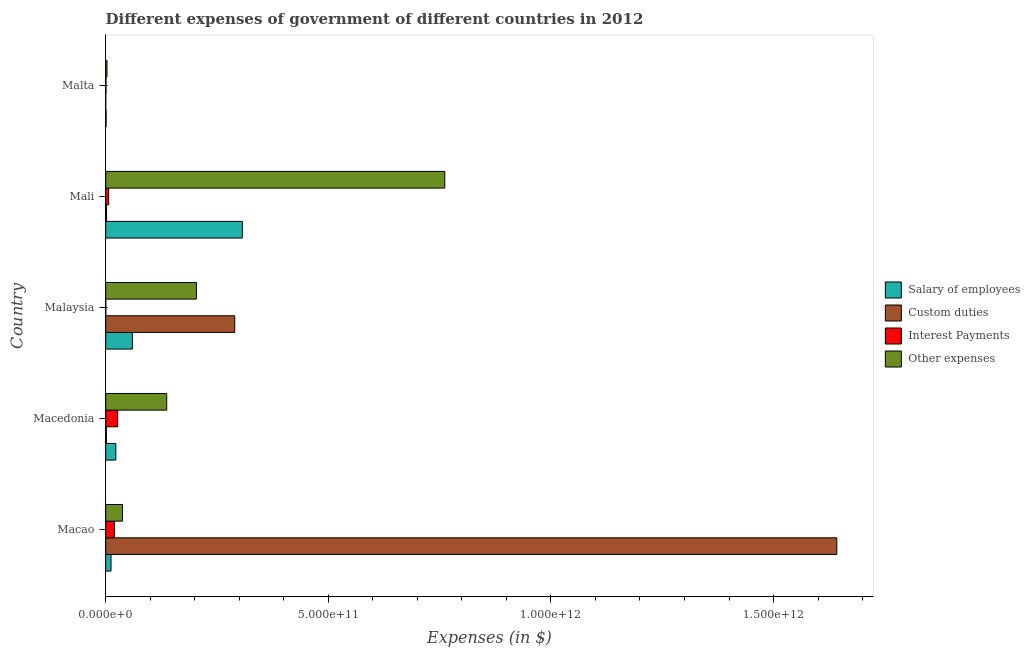How many different coloured bars are there?
Your answer should be very brief. 4. How many groups of bars are there?
Ensure brevity in your answer.  5. How many bars are there on the 2nd tick from the bottom?
Your answer should be compact. 4. What is the label of the 4th group of bars from the top?
Offer a terse response. Macedonia. What is the amount spent on other expenses in Malaysia?
Give a very brief answer. 2.04e+11. Across all countries, what is the maximum amount spent on interest payments?
Provide a succinct answer. 2.69e+1. In which country was the amount spent on interest payments maximum?
Your answer should be very brief. Macedonia. In which country was the amount spent on salary of employees minimum?
Your response must be concise. Malta. What is the total amount spent on custom duties in the graph?
Provide a succinct answer. 1.94e+12. What is the difference between the amount spent on other expenses in Macao and that in Malaysia?
Your response must be concise. -1.66e+11. What is the difference between the amount spent on other expenses in Mali and the amount spent on custom duties in Macedonia?
Offer a very short reply. 7.60e+11. What is the average amount spent on custom duties per country?
Your response must be concise. 3.87e+11. What is the difference between the amount spent on other expenses and amount spent on custom duties in Malta?
Provide a succinct answer. 2.90e+09. What is the ratio of the amount spent on interest payments in Mali to that in Malta?
Give a very brief answer. 9.92. What is the difference between the highest and the second highest amount spent on custom duties?
Your answer should be compact. 1.35e+12. What is the difference between the highest and the lowest amount spent on salary of employees?
Make the answer very short. 3.06e+11. In how many countries, is the amount spent on other expenses greater than the average amount spent on other expenses taken over all countries?
Your answer should be compact. 1. Is the sum of the amount spent on custom duties in Macedonia and Malaysia greater than the maximum amount spent on other expenses across all countries?
Offer a terse response. No. What does the 4th bar from the top in Mali represents?
Provide a succinct answer. Salary of employees. What does the 4th bar from the bottom in Malaysia represents?
Your answer should be very brief. Other expenses. How many bars are there?
Keep it short and to the point. 20. How many countries are there in the graph?
Your answer should be compact. 5. What is the difference between two consecutive major ticks on the X-axis?
Your response must be concise. 5.00e+11. Are the values on the major ticks of X-axis written in scientific E-notation?
Keep it short and to the point. Yes. Where does the legend appear in the graph?
Your response must be concise. Center right. What is the title of the graph?
Offer a very short reply. Different expenses of government of different countries in 2012. What is the label or title of the X-axis?
Make the answer very short. Expenses (in $). What is the Expenses (in $) in Salary of employees in Macao?
Offer a very short reply. 1.19e+1. What is the Expenses (in $) of Custom duties in Macao?
Your answer should be very brief. 1.64e+12. What is the Expenses (in $) in Interest Payments in Macao?
Keep it short and to the point. 1.95e+1. What is the Expenses (in $) of Other expenses in Macao?
Give a very brief answer. 3.76e+1. What is the Expenses (in $) in Salary of employees in Macedonia?
Offer a terse response. 2.27e+1. What is the Expenses (in $) in Custom duties in Macedonia?
Your answer should be very brief. 1.53e+09. What is the Expenses (in $) in Interest Payments in Macedonia?
Make the answer very short. 2.69e+1. What is the Expenses (in $) of Other expenses in Macedonia?
Offer a very short reply. 1.37e+11. What is the Expenses (in $) in Salary of employees in Malaysia?
Offer a terse response. 6.00e+1. What is the Expenses (in $) of Custom duties in Malaysia?
Make the answer very short. 2.90e+11. What is the Expenses (in $) in Interest Payments in Malaysia?
Provide a succinct answer. 2.13e+08. What is the Expenses (in $) of Other expenses in Malaysia?
Offer a terse response. 2.04e+11. What is the Expenses (in $) in Salary of employees in Mali?
Ensure brevity in your answer.  3.07e+11. What is the Expenses (in $) of Custom duties in Mali?
Provide a short and direct response. 1.95e+09. What is the Expenses (in $) of Interest Payments in Mali?
Provide a short and direct response. 6.61e+09. What is the Expenses (in $) of Other expenses in Mali?
Offer a terse response. 7.62e+11. What is the Expenses (in $) of Salary of employees in Malta?
Provide a succinct answer. 9.07e+08. What is the Expenses (in $) of Custom duties in Malta?
Make the answer very short. 1.00e+06. What is the Expenses (in $) in Interest Payments in Malta?
Your answer should be very brief. 6.66e+08. What is the Expenses (in $) in Other expenses in Malta?
Offer a very short reply. 2.90e+09. Across all countries, what is the maximum Expenses (in $) in Salary of employees?
Your response must be concise. 3.07e+11. Across all countries, what is the maximum Expenses (in $) of Custom duties?
Offer a terse response. 1.64e+12. Across all countries, what is the maximum Expenses (in $) of Interest Payments?
Make the answer very short. 2.69e+1. Across all countries, what is the maximum Expenses (in $) in Other expenses?
Ensure brevity in your answer.  7.62e+11. Across all countries, what is the minimum Expenses (in $) of Salary of employees?
Your response must be concise. 9.07e+08. Across all countries, what is the minimum Expenses (in $) in Interest Payments?
Ensure brevity in your answer.  2.13e+08. Across all countries, what is the minimum Expenses (in $) of Other expenses?
Offer a terse response. 2.90e+09. What is the total Expenses (in $) in Salary of employees in the graph?
Give a very brief answer. 4.02e+11. What is the total Expenses (in $) in Custom duties in the graph?
Ensure brevity in your answer.  1.94e+12. What is the total Expenses (in $) of Interest Payments in the graph?
Provide a succinct answer. 5.39e+1. What is the total Expenses (in $) of Other expenses in the graph?
Provide a succinct answer. 1.14e+12. What is the difference between the Expenses (in $) of Salary of employees in Macao and that in Macedonia?
Keep it short and to the point. -1.08e+1. What is the difference between the Expenses (in $) in Custom duties in Macao and that in Macedonia?
Give a very brief answer. 1.64e+12. What is the difference between the Expenses (in $) in Interest Payments in Macao and that in Macedonia?
Your response must be concise. -7.35e+09. What is the difference between the Expenses (in $) in Other expenses in Macao and that in Macedonia?
Your answer should be very brief. -9.95e+1. What is the difference between the Expenses (in $) of Salary of employees in Macao and that in Malaysia?
Provide a succinct answer. -4.81e+1. What is the difference between the Expenses (in $) in Custom duties in Macao and that in Malaysia?
Make the answer very short. 1.35e+12. What is the difference between the Expenses (in $) in Interest Payments in Macao and that in Malaysia?
Ensure brevity in your answer.  1.93e+1. What is the difference between the Expenses (in $) of Other expenses in Macao and that in Malaysia?
Give a very brief answer. -1.66e+11. What is the difference between the Expenses (in $) of Salary of employees in Macao and that in Mali?
Offer a terse response. -2.95e+11. What is the difference between the Expenses (in $) in Custom duties in Macao and that in Mali?
Make the answer very short. 1.64e+12. What is the difference between the Expenses (in $) in Interest Payments in Macao and that in Mali?
Provide a succinct answer. 1.29e+1. What is the difference between the Expenses (in $) of Other expenses in Macao and that in Mali?
Your answer should be very brief. -7.24e+11. What is the difference between the Expenses (in $) of Salary of employees in Macao and that in Malta?
Offer a terse response. 1.10e+1. What is the difference between the Expenses (in $) in Custom duties in Macao and that in Malta?
Provide a short and direct response. 1.64e+12. What is the difference between the Expenses (in $) in Interest Payments in Macao and that in Malta?
Your response must be concise. 1.89e+1. What is the difference between the Expenses (in $) of Other expenses in Macao and that in Malta?
Make the answer very short. 3.47e+1. What is the difference between the Expenses (in $) of Salary of employees in Macedonia and that in Malaysia?
Offer a terse response. -3.73e+1. What is the difference between the Expenses (in $) of Custom duties in Macedonia and that in Malaysia?
Make the answer very short. -2.88e+11. What is the difference between the Expenses (in $) of Interest Payments in Macedonia and that in Malaysia?
Provide a short and direct response. 2.67e+1. What is the difference between the Expenses (in $) in Other expenses in Macedonia and that in Malaysia?
Your answer should be very brief. -6.67e+1. What is the difference between the Expenses (in $) of Salary of employees in Macedonia and that in Mali?
Give a very brief answer. -2.84e+11. What is the difference between the Expenses (in $) in Custom duties in Macedonia and that in Mali?
Offer a very short reply. -4.24e+08. What is the difference between the Expenses (in $) of Interest Payments in Macedonia and that in Mali?
Your response must be concise. 2.03e+1. What is the difference between the Expenses (in $) of Other expenses in Macedonia and that in Mali?
Your response must be concise. -6.25e+11. What is the difference between the Expenses (in $) in Salary of employees in Macedonia and that in Malta?
Your response must be concise. 2.18e+1. What is the difference between the Expenses (in $) in Custom duties in Macedonia and that in Malta?
Offer a terse response. 1.53e+09. What is the difference between the Expenses (in $) in Interest Payments in Macedonia and that in Malta?
Your response must be concise. 2.62e+1. What is the difference between the Expenses (in $) of Other expenses in Macedonia and that in Malta?
Provide a short and direct response. 1.34e+11. What is the difference between the Expenses (in $) in Salary of employees in Malaysia and that in Mali?
Your response must be concise. -2.47e+11. What is the difference between the Expenses (in $) in Custom duties in Malaysia and that in Mali?
Offer a very short reply. 2.88e+11. What is the difference between the Expenses (in $) of Interest Payments in Malaysia and that in Mali?
Provide a short and direct response. -6.40e+09. What is the difference between the Expenses (in $) in Other expenses in Malaysia and that in Mali?
Offer a very short reply. -5.58e+11. What is the difference between the Expenses (in $) in Salary of employees in Malaysia and that in Malta?
Your response must be concise. 5.91e+1. What is the difference between the Expenses (in $) in Custom duties in Malaysia and that in Malta?
Offer a terse response. 2.90e+11. What is the difference between the Expenses (in $) of Interest Payments in Malaysia and that in Malta?
Make the answer very short. -4.54e+08. What is the difference between the Expenses (in $) of Other expenses in Malaysia and that in Malta?
Provide a succinct answer. 2.01e+11. What is the difference between the Expenses (in $) in Salary of employees in Mali and that in Malta?
Offer a very short reply. 3.06e+11. What is the difference between the Expenses (in $) in Custom duties in Mali and that in Malta?
Make the answer very short. 1.95e+09. What is the difference between the Expenses (in $) in Interest Payments in Mali and that in Malta?
Your answer should be very brief. 5.94e+09. What is the difference between the Expenses (in $) of Other expenses in Mali and that in Malta?
Make the answer very short. 7.59e+11. What is the difference between the Expenses (in $) of Salary of employees in Macao and the Expenses (in $) of Custom duties in Macedonia?
Ensure brevity in your answer.  1.04e+1. What is the difference between the Expenses (in $) of Salary of employees in Macao and the Expenses (in $) of Interest Payments in Macedonia?
Your answer should be very brief. -1.49e+1. What is the difference between the Expenses (in $) of Salary of employees in Macao and the Expenses (in $) of Other expenses in Macedonia?
Provide a short and direct response. -1.25e+11. What is the difference between the Expenses (in $) of Custom duties in Macao and the Expenses (in $) of Interest Payments in Macedonia?
Give a very brief answer. 1.62e+12. What is the difference between the Expenses (in $) of Custom duties in Macao and the Expenses (in $) of Other expenses in Macedonia?
Ensure brevity in your answer.  1.50e+12. What is the difference between the Expenses (in $) of Interest Payments in Macao and the Expenses (in $) of Other expenses in Macedonia?
Ensure brevity in your answer.  -1.18e+11. What is the difference between the Expenses (in $) of Salary of employees in Macao and the Expenses (in $) of Custom duties in Malaysia?
Provide a succinct answer. -2.78e+11. What is the difference between the Expenses (in $) of Salary of employees in Macao and the Expenses (in $) of Interest Payments in Malaysia?
Ensure brevity in your answer.  1.17e+1. What is the difference between the Expenses (in $) in Salary of employees in Macao and the Expenses (in $) in Other expenses in Malaysia?
Make the answer very short. -1.92e+11. What is the difference between the Expenses (in $) in Custom duties in Macao and the Expenses (in $) in Interest Payments in Malaysia?
Provide a succinct answer. 1.64e+12. What is the difference between the Expenses (in $) of Custom duties in Macao and the Expenses (in $) of Other expenses in Malaysia?
Ensure brevity in your answer.  1.44e+12. What is the difference between the Expenses (in $) in Interest Payments in Macao and the Expenses (in $) in Other expenses in Malaysia?
Your answer should be very brief. -1.84e+11. What is the difference between the Expenses (in $) of Salary of employees in Macao and the Expenses (in $) of Custom duties in Mali?
Your response must be concise. 9.99e+09. What is the difference between the Expenses (in $) in Salary of employees in Macao and the Expenses (in $) in Interest Payments in Mali?
Give a very brief answer. 5.33e+09. What is the difference between the Expenses (in $) in Salary of employees in Macao and the Expenses (in $) in Other expenses in Mali?
Keep it short and to the point. -7.50e+11. What is the difference between the Expenses (in $) of Custom duties in Macao and the Expenses (in $) of Interest Payments in Mali?
Keep it short and to the point. 1.64e+12. What is the difference between the Expenses (in $) of Custom duties in Macao and the Expenses (in $) of Other expenses in Mali?
Ensure brevity in your answer.  8.80e+11. What is the difference between the Expenses (in $) of Interest Payments in Macao and the Expenses (in $) of Other expenses in Mali?
Make the answer very short. -7.42e+11. What is the difference between the Expenses (in $) in Salary of employees in Macao and the Expenses (in $) in Custom duties in Malta?
Keep it short and to the point. 1.19e+1. What is the difference between the Expenses (in $) in Salary of employees in Macao and the Expenses (in $) in Interest Payments in Malta?
Keep it short and to the point. 1.13e+1. What is the difference between the Expenses (in $) in Salary of employees in Macao and the Expenses (in $) in Other expenses in Malta?
Give a very brief answer. 9.04e+09. What is the difference between the Expenses (in $) of Custom duties in Macao and the Expenses (in $) of Interest Payments in Malta?
Give a very brief answer. 1.64e+12. What is the difference between the Expenses (in $) in Custom duties in Macao and the Expenses (in $) in Other expenses in Malta?
Offer a very short reply. 1.64e+12. What is the difference between the Expenses (in $) in Interest Payments in Macao and the Expenses (in $) in Other expenses in Malta?
Give a very brief answer. 1.66e+1. What is the difference between the Expenses (in $) in Salary of employees in Macedonia and the Expenses (in $) in Custom duties in Malaysia?
Provide a succinct answer. -2.67e+11. What is the difference between the Expenses (in $) of Salary of employees in Macedonia and the Expenses (in $) of Interest Payments in Malaysia?
Offer a very short reply. 2.25e+1. What is the difference between the Expenses (in $) in Salary of employees in Macedonia and the Expenses (in $) in Other expenses in Malaysia?
Your answer should be very brief. -1.81e+11. What is the difference between the Expenses (in $) in Custom duties in Macedonia and the Expenses (in $) in Interest Payments in Malaysia?
Provide a short and direct response. 1.31e+09. What is the difference between the Expenses (in $) in Custom duties in Macedonia and the Expenses (in $) in Other expenses in Malaysia?
Your answer should be very brief. -2.02e+11. What is the difference between the Expenses (in $) of Interest Payments in Macedonia and the Expenses (in $) of Other expenses in Malaysia?
Ensure brevity in your answer.  -1.77e+11. What is the difference between the Expenses (in $) of Salary of employees in Macedonia and the Expenses (in $) of Custom duties in Mali?
Offer a terse response. 2.08e+1. What is the difference between the Expenses (in $) in Salary of employees in Macedonia and the Expenses (in $) in Interest Payments in Mali?
Your response must be concise. 1.61e+1. What is the difference between the Expenses (in $) in Salary of employees in Macedonia and the Expenses (in $) in Other expenses in Mali?
Provide a short and direct response. -7.39e+11. What is the difference between the Expenses (in $) of Custom duties in Macedonia and the Expenses (in $) of Interest Payments in Mali?
Give a very brief answer. -5.08e+09. What is the difference between the Expenses (in $) of Custom duties in Macedonia and the Expenses (in $) of Other expenses in Mali?
Give a very brief answer. -7.60e+11. What is the difference between the Expenses (in $) of Interest Payments in Macedonia and the Expenses (in $) of Other expenses in Mali?
Your answer should be compact. -7.35e+11. What is the difference between the Expenses (in $) of Salary of employees in Macedonia and the Expenses (in $) of Custom duties in Malta?
Provide a short and direct response. 2.27e+1. What is the difference between the Expenses (in $) in Salary of employees in Macedonia and the Expenses (in $) in Interest Payments in Malta?
Your answer should be compact. 2.20e+1. What is the difference between the Expenses (in $) of Salary of employees in Macedonia and the Expenses (in $) of Other expenses in Malta?
Offer a terse response. 1.98e+1. What is the difference between the Expenses (in $) of Custom duties in Macedonia and the Expenses (in $) of Interest Payments in Malta?
Offer a terse response. 8.60e+08. What is the difference between the Expenses (in $) of Custom duties in Macedonia and the Expenses (in $) of Other expenses in Malta?
Make the answer very short. -1.38e+09. What is the difference between the Expenses (in $) in Interest Payments in Macedonia and the Expenses (in $) in Other expenses in Malta?
Provide a short and direct response. 2.40e+1. What is the difference between the Expenses (in $) in Salary of employees in Malaysia and the Expenses (in $) in Custom duties in Mali?
Offer a terse response. 5.81e+1. What is the difference between the Expenses (in $) of Salary of employees in Malaysia and the Expenses (in $) of Interest Payments in Mali?
Offer a very short reply. 5.34e+1. What is the difference between the Expenses (in $) of Salary of employees in Malaysia and the Expenses (in $) of Other expenses in Mali?
Your response must be concise. -7.02e+11. What is the difference between the Expenses (in $) in Custom duties in Malaysia and the Expenses (in $) in Interest Payments in Mali?
Provide a succinct answer. 2.83e+11. What is the difference between the Expenses (in $) in Custom duties in Malaysia and the Expenses (in $) in Other expenses in Mali?
Provide a succinct answer. -4.72e+11. What is the difference between the Expenses (in $) in Interest Payments in Malaysia and the Expenses (in $) in Other expenses in Mali?
Your answer should be very brief. -7.61e+11. What is the difference between the Expenses (in $) of Salary of employees in Malaysia and the Expenses (in $) of Custom duties in Malta?
Ensure brevity in your answer.  6.00e+1. What is the difference between the Expenses (in $) of Salary of employees in Malaysia and the Expenses (in $) of Interest Payments in Malta?
Your answer should be compact. 5.93e+1. What is the difference between the Expenses (in $) in Salary of employees in Malaysia and the Expenses (in $) in Other expenses in Malta?
Your response must be concise. 5.71e+1. What is the difference between the Expenses (in $) in Custom duties in Malaysia and the Expenses (in $) in Interest Payments in Malta?
Provide a succinct answer. 2.89e+11. What is the difference between the Expenses (in $) in Custom duties in Malaysia and the Expenses (in $) in Other expenses in Malta?
Offer a terse response. 2.87e+11. What is the difference between the Expenses (in $) in Interest Payments in Malaysia and the Expenses (in $) in Other expenses in Malta?
Provide a succinct answer. -2.69e+09. What is the difference between the Expenses (in $) in Salary of employees in Mali and the Expenses (in $) in Custom duties in Malta?
Keep it short and to the point. 3.07e+11. What is the difference between the Expenses (in $) in Salary of employees in Mali and the Expenses (in $) in Interest Payments in Malta?
Give a very brief answer. 3.06e+11. What is the difference between the Expenses (in $) of Salary of employees in Mali and the Expenses (in $) of Other expenses in Malta?
Your response must be concise. 3.04e+11. What is the difference between the Expenses (in $) in Custom duties in Mali and the Expenses (in $) in Interest Payments in Malta?
Provide a short and direct response. 1.28e+09. What is the difference between the Expenses (in $) in Custom duties in Mali and the Expenses (in $) in Other expenses in Malta?
Provide a short and direct response. -9.53e+08. What is the difference between the Expenses (in $) of Interest Payments in Mali and the Expenses (in $) of Other expenses in Malta?
Provide a short and direct response. 3.71e+09. What is the average Expenses (in $) of Salary of employees per country?
Offer a terse response. 8.05e+1. What is the average Expenses (in $) of Custom duties per country?
Ensure brevity in your answer.  3.87e+11. What is the average Expenses (in $) of Interest Payments per country?
Offer a very short reply. 1.08e+1. What is the average Expenses (in $) in Other expenses per country?
Provide a succinct answer. 2.29e+11. What is the difference between the Expenses (in $) of Salary of employees and Expenses (in $) of Custom duties in Macao?
Offer a very short reply. -1.63e+12. What is the difference between the Expenses (in $) in Salary of employees and Expenses (in $) in Interest Payments in Macao?
Make the answer very short. -7.59e+09. What is the difference between the Expenses (in $) in Salary of employees and Expenses (in $) in Other expenses in Macao?
Provide a succinct answer. -2.57e+1. What is the difference between the Expenses (in $) in Custom duties and Expenses (in $) in Interest Payments in Macao?
Keep it short and to the point. 1.62e+12. What is the difference between the Expenses (in $) in Custom duties and Expenses (in $) in Other expenses in Macao?
Provide a short and direct response. 1.60e+12. What is the difference between the Expenses (in $) in Interest Payments and Expenses (in $) in Other expenses in Macao?
Make the answer very short. -1.81e+1. What is the difference between the Expenses (in $) of Salary of employees and Expenses (in $) of Custom duties in Macedonia?
Your answer should be very brief. 2.12e+1. What is the difference between the Expenses (in $) in Salary of employees and Expenses (in $) in Interest Payments in Macedonia?
Your answer should be very brief. -4.18e+09. What is the difference between the Expenses (in $) of Salary of employees and Expenses (in $) of Other expenses in Macedonia?
Offer a very short reply. -1.14e+11. What is the difference between the Expenses (in $) in Custom duties and Expenses (in $) in Interest Payments in Macedonia?
Your response must be concise. -2.54e+1. What is the difference between the Expenses (in $) in Custom duties and Expenses (in $) in Other expenses in Macedonia?
Keep it short and to the point. -1.36e+11. What is the difference between the Expenses (in $) of Interest Payments and Expenses (in $) of Other expenses in Macedonia?
Ensure brevity in your answer.  -1.10e+11. What is the difference between the Expenses (in $) in Salary of employees and Expenses (in $) in Custom duties in Malaysia?
Offer a very short reply. -2.30e+11. What is the difference between the Expenses (in $) in Salary of employees and Expenses (in $) in Interest Payments in Malaysia?
Give a very brief answer. 5.98e+1. What is the difference between the Expenses (in $) of Salary of employees and Expenses (in $) of Other expenses in Malaysia?
Give a very brief answer. -1.44e+11. What is the difference between the Expenses (in $) of Custom duties and Expenses (in $) of Interest Payments in Malaysia?
Ensure brevity in your answer.  2.90e+11. What is the difference between the Expenses (in $) in Custom duties and Expenses (in $) in Other expenses in Malaysia?
Provide a short and direct response. 8.61e+1. What is the difference between the Expenses (in $) of Interest Payments and Expenses (in $) of Other expenses in Malaysia?
Provide a succinct answer. -2.04e+11. What is the difference between the Expenses (in $) of Salary of employees and Expenses (in $) of Custom duties in Mali?
Your response must be concise. 3.05e+11. What is the difference between the Expenses (in $) of Salary of employees and Expenses (in $) of Interest Payments in Mali?
Your answer should be compact. 3.00e+11. What is the difference between the Expenses (in $) in Salary of employees and Expenses (in $) in Other expenses in Mali?
Your answer should be compact. -4.55e+11. What is the difference between the Expenses (in $) in Custom duties and Expenses (in $) in Interest Payments in Mali?
Your answer should be very brief. -4.66e+09. What is the difference between the Expenses (in $) in Custom duties and Expenses (in $) in Other expenses in Mali?
Your response must be concise. -7.60e+11. What is the difference between the Expenses (in $) in Interest Payments and Expenses (in $) in Other expenses in Mali?
Your answer should be very brief. -7.55e+11. What is the difference between the Expenses (in $) of Salary of employees and Expenses (in $) of Custom duties in Malta?
Provide a succinct answer. 9.06e+08. What is the difference between the Expenses (in $) in Salary of employees and Expenses (in $) in Interest Payments in Malta?
Offer a terse response. 2.40e+08. What is the difference between the Expenses (in $) in Salary of employees and Expenses (in $) in Other expenses in Malta?
Your answer should be compact. -2.00e+09. What is the difference between the Expenses (in $) of Custom duties and Expenses (in $) of Interest Payments in Malta?
Provide a short and direct response. -6.65e+08. What is the difference between the Expenses (in $) in Custom duties and Expenses (in $) in Other expenses in Malta?
Give a very brief answer. -2.90e+09. What is the difference between the Expenses (in $) in Interest Payments and Expenses (in $) in Other expenses in Malta?
Offer a terse response. -2.24e+09. What is the ratio of the Expenses (in $) of Salary of employees in Macao to that in Macedonia?
Offer a terse response. 0.53. What is the ratio of the Expenses (in $) in Custom duties in Macao to that in Macedonia?
Provide a short and direct response. 1076.05. What is the ratio of the Expenses (in $) of Interest Payments in Macao to that in Macedonia?
Provide a succinct answer. 0.73. What is the ratio of the Expenses (in $) of Other expenses in Macao to that in Macedonia?
Provide a succinct answer. 0.27. What is the ratio of the Expenses (in $) in Salary of employees in Macao to that in Malaysia?
Ensure brevity in your answer.  0.2. What is the ratio of the Expenses (in $) in Custom duties in Macao to that in Malaysia?
Your answer should be very brief. 5.67. What is the ratio of the Expenses (in $) in Interest Payments in Macao to that in Malaysia?
Provide a short and direct response. 91.8. What is the ratio of the Expenses (in $) in Other expenses in Macao to that in Malaysia?
Your response must be concise. 0.18. What is the ratio of the Expenses (in $) in Salary of employees in Macao to that in Mali?
Your response must be concise. 0.04. What is the ratio of the Expenses (in $) in Custom duties in Macao to that in Mali?
Offer a very short reply. 842.09. What is the ratio of the Expenses (in $) in Interest Payments in Macao to that in Mali?
Provide a short and direct response. 2.96. What is the ratio of the Expenses (in $) in Other expenses in Macao to that in Mali?
Keep it short and to the point. 0.05. What is the ratio of the Expenses (in $) in Salary of employees in Macao to that in Malta?
Your answer should be compact. 13.18. What is the ratio of the Expenses (in $) of Custom duties in Macao to that in Malta?
Ensure brevity in your answer.  1.64e+06. What is the ratio of the Expenses (in $) in Interest Payments in Macao to that in Malta?
Ensure brevity in your answer.  29.32. What is the ratio of the Expenses (in $) of Other expenses in Macao to that in Malta?
Ensure brevity in your answer.  12.96. What is the ratio of the Expenses (in $) of Salary of employees in Macedonia to that in Malaysia?
Ensure brevity in your answer.  0.38. What is the ratio of the Expenses (in $) in Custom duties in Macedonia to that in Malaysia?
Your answer should be compact. 0.01. What is the ratio of the Expenses (in $) of Interest Payments in Macedonia to that in Malaysia?
Your answer should be very brief. 126.34. What is the ratio of the Expenses (in $) in Other expenses in Macedonia to that in Malaysia?
Offer a very short reply. 0.67. What is the ratio of the Expenses (in $) in Salary of employees in Macedonia to that in Mali?
Offer a very short reply. 0.07. What is the ratio of the Expenses (in $) in Custom duties in Macedonia to that in Mali?
Give a very brief answer. 0.78. What is the ratio of the Expenses (in $) in Interest Payments in Macedonia to that in Mali?
Your answer should be very brief. 4.07. What is the ratio of the Expenses (in $) in Other expenses in Macedonia to that in Mali?
Ensure brevity in your answer.  0.18. What is the ratio of the Expenses (in $) in Salary of employees in Macedonia to that in Malta?
Your response must be concise. 25.06. What is the ratio of the Expenses (in $) in Custom duties in Macedonia to that in Malta?
Your answer should be compact. 1526.02. What is the ratio of the Expenses (in $) of Interest Payments in Macedonia to that in Malta?
Keep it short and to the point. 40.35. What is the ratio of the Expenses (in $) of Other expenses in Macedonia to that in Malta?
Provide a succinct answer. 47.23. What is the ratio of the Expenses (in $) of Salary of employees in Malaysia to that in Mali?
Ensure brevity in your answer.  0.2. What is the ratio of the Expenses (in $) of Custom duties in Malaysia to that in Mali?
Provide a succinct answer. 148.65. What is the ratio of the Expenses (in $) of Interest Payments in Malaysia to that in Mali?
Provide a short and direct response. 0.03. What is the ratio of the Expenses (in $) in Other expenses in Malaysia to that in Mali?
Ensure brevity in your answer.  0.27. What is the ratio of the Expenses (in $) in Salary of employees in Malaysia to that in Malta?
Your answer should be compact. 66.2. What is the ratio of the Expenses (in $) of Custom duties in Malaysia to that in Malta?
Your response must be concise. 2.90e+05. What is the ratio of the Expenses (in $) in Interest Payments in Malaysia to that in Malta?
Your response must be concise. 0.32. What is the ratio of the Expenses (in $) of Other expenses in Malaysia to that in Malta?
Offer a very short reply. 70.2. What is the ratio of the Expenses (in $) in Salary of employees in Mali to that in Malta?
Your answer should be compact. 338.56. What is the ratio of the Expenses (in $) of Custom duties in Mali to that in Malta?
Ensure brevity in your answer.  1950. What is the ratio of the Expenses (in $) in Interest Payments in Mali to that in Malta?
Your answer should be very brief. 9.92. What is the ratio of the Expenses (in $) in Other expenses in Mali to that in Malta?
Offer a very short reply. 262.38. What is the difference between the highest and the second highest Expenses (in $) of Salary of employees?
Give a very brief answer. 2.47e+11. What is the difference between the highest and the second highest Expenses (in $) in Custom duties?
Ensure brevity in your answer.  1.35e+12. What is the difference between the highest and the second highest Expenses (in $) of Interest Payments?
Your answer should be very brief. 7.35e+09. What is the difference between the highest and the second highest Expenses (in $) in Other expenses?
Provide a short and direct response. 5.58e+11. What is the difference between the highest and the lowest Expenses (in $) of Salary of employees?
Your response must be concise. 3.06e+11. What is the difference between the highest and the lowest Expenses (in $) in Custom duties?
Offer a terse response. 1.64e+12. What is the difference between the highest and the lowest Expenses (in $) of Interest Payments?
Your answer should be very brief. 2.67e+1. What is the difference between the highest and the lowest Expenses (in $) of Other expenses?
Provide a short and direct response. 7.59e+11. 